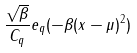<formula> <loc_0><loc_0><loc_500><loc_500>\frac { \sqrt { \beta } } { C _ { q } } e _ { q } ( - \beta ( x - \mu ) ^ { 2 } )</formula> 